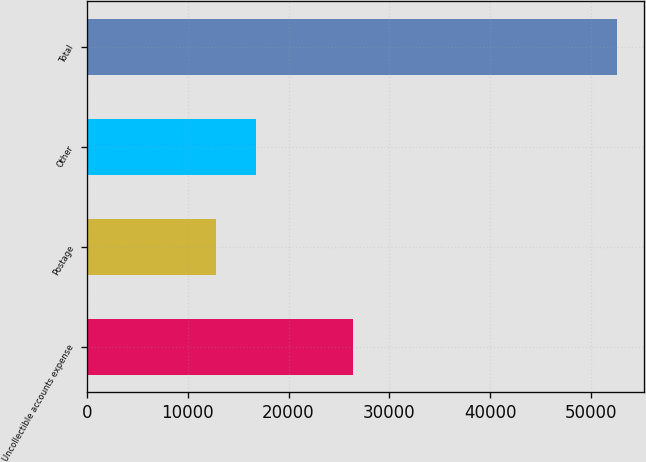<chart> <loc_0><loc_0><loc_500><loc_500><bar_chart><fcel>Uncollectible accounts expense<fcel>Postage<fcel>Other<fcel>Total<nl><fcel>26443<fcel>12757<fcel>16743.8<fcel>52625<nl></chart> 